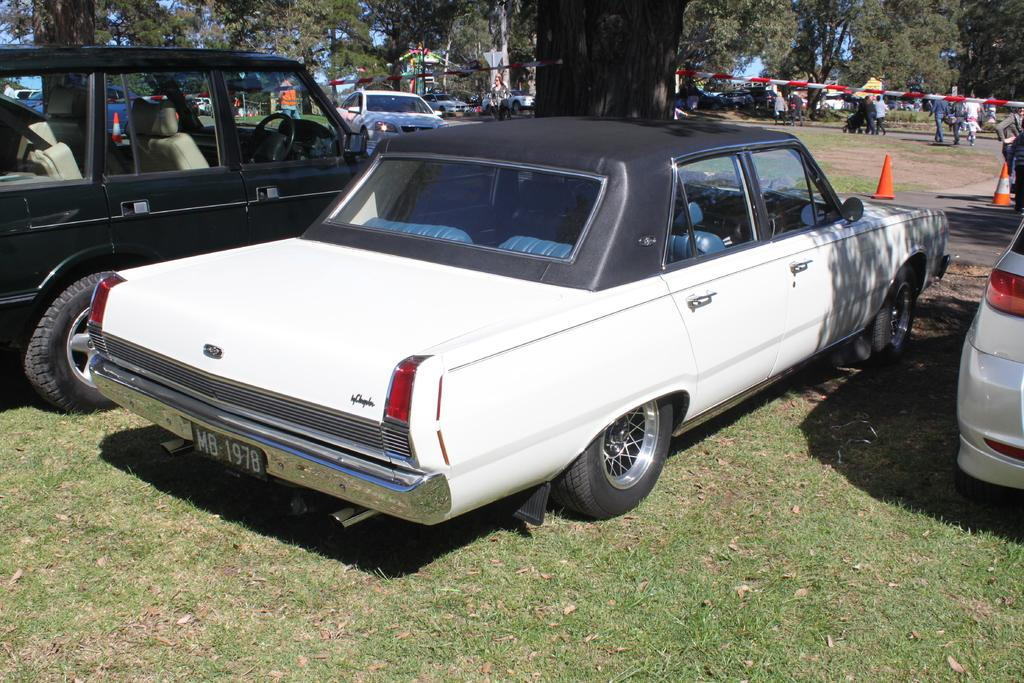What type of vehicles can be seen on the ground in the image? There are cars on the ground in the image. Can you describe the people in the image? There are people in the image, but their specific actions or appearances are not mentioned in the provided facts. What objects are used to direct traffic in the image? Traffic cones are present in the image. What other objects can be seen in the image besides cars and traffic cones? Rods are visible in the image. What type of natural environment is present in the image? Grass is present in the image, and there are trees in the background. What is visible in the background of the image? The sky is visible in the background of the image. Can you tell me how many planes are flying in the image? There are no planes visible in the image; it only features cars, people, traffic cones, rods, grass, trees, and the sky. What type of edge is present in the image? There is no specific edge mentioned in the provided facts, as the image seems to be a general scene without a defined border or edge. 